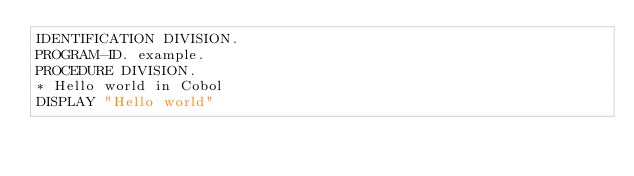<code> <loc_0><loc_0><loc_500><loc_500><_COBOL_>IDENTIFICATION DIVISION.
PROGRAM-ID. example.
PROCEDURE DIVISION.
* Hello world in Cobol
DISPLAY "Hello world"</code> 